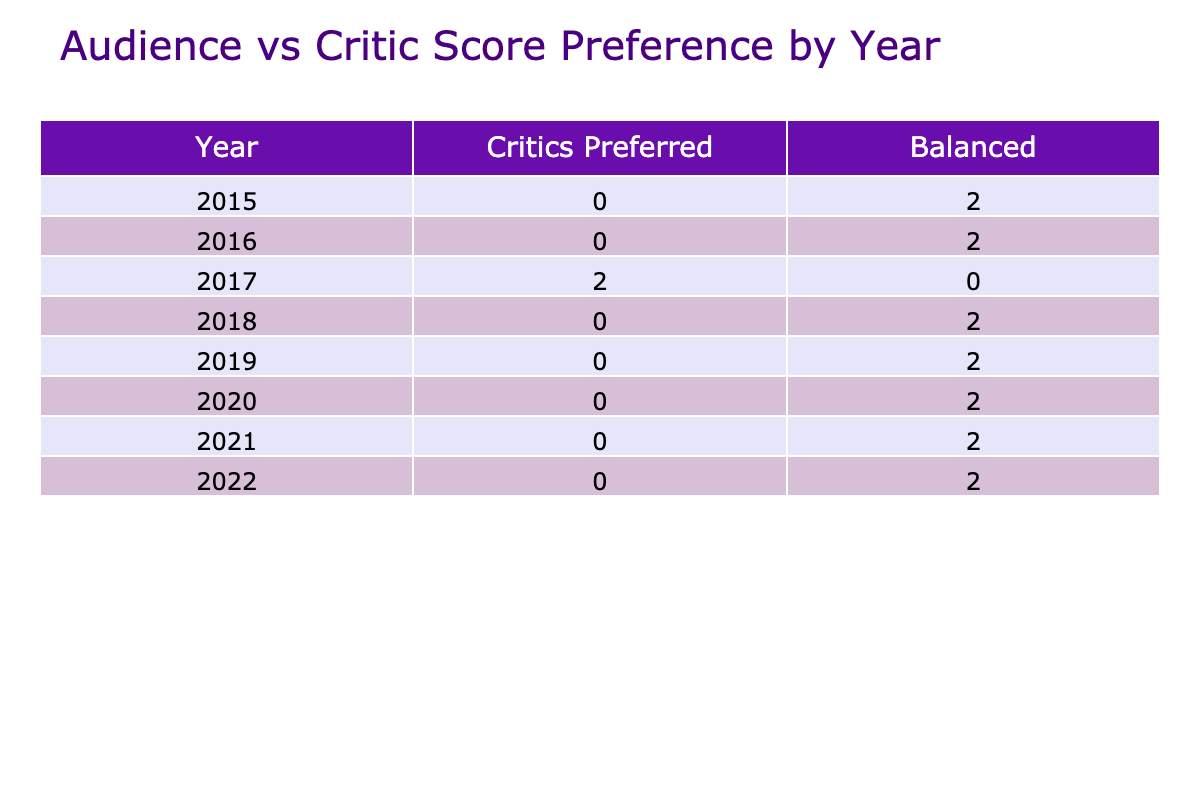What year had the most films categorized as "Audience Preferred"? By looking at the table, we can check the number of "Audience Preferred" films for each year. In 2017, there is 1 film ("Star Wars: The Last Jedi") that is categorized as "Audience Preferred." In 2018 there are no films in this category, and in subsequent years such as 2020 and 2021, there are also no films listed under "Audience Preferred." Therefore, the answer is 2017 since it had the only film in that category.
Answer: 2017 What is the total count of films categorized as "Critics Preferred" across all years? To find this, we need to count the films under the "Critics Preferred" category across all years. The years that have films in this category are 2017 ("Get Out"), 2020 ("Tenet"), and 2021 ("Dune"). Thus, the total count is 3 films.
Answer: 3 What year had a balanced score preference? According to the table, a "Balanced" score preference indicates that the audience score and critic score were nearly the same. The years that had films categorized as "Balanced" are 2019 with "Once Upon a Time in Hollywood". So, the year with a balanced score is 2019.
Answer: 2019 Did any year have the same number of "Balanced" films as "Critics Preferred" films? By looking at the table, we see that the only year with "Balanced" films is 2019, which has 1 film. The years with "Critics Preferred" films include 2017 (1 film), 2020 (1 film), and 2021 (1 film). Hence, both 2019 and any of the other years listed have the same number (1) of films in their respective categories. Therefore, the answer is yes.
Answer: Yes Which year had the highest combined audience and critic scores among its films? To find the year with the highest combined scores, we need to add the audience and critic scores for films in each year and find the sum. For example, in 2015, the total is (98 + 94) + (82 + 78) = 352, 2016 has (91 + 91) + (88 + 93) = 363, 2017 has (86 + 98) + (42 + 91) = 317, and for 2018, it equals (96 + 97) + (89 + 90) = 372, and higher combinations reaching up to 386 in 2019 with (99 + 98) + (85 + 85). Therefore, the 2019 total is the highest with the combined score of 386.
Answer: 2019 